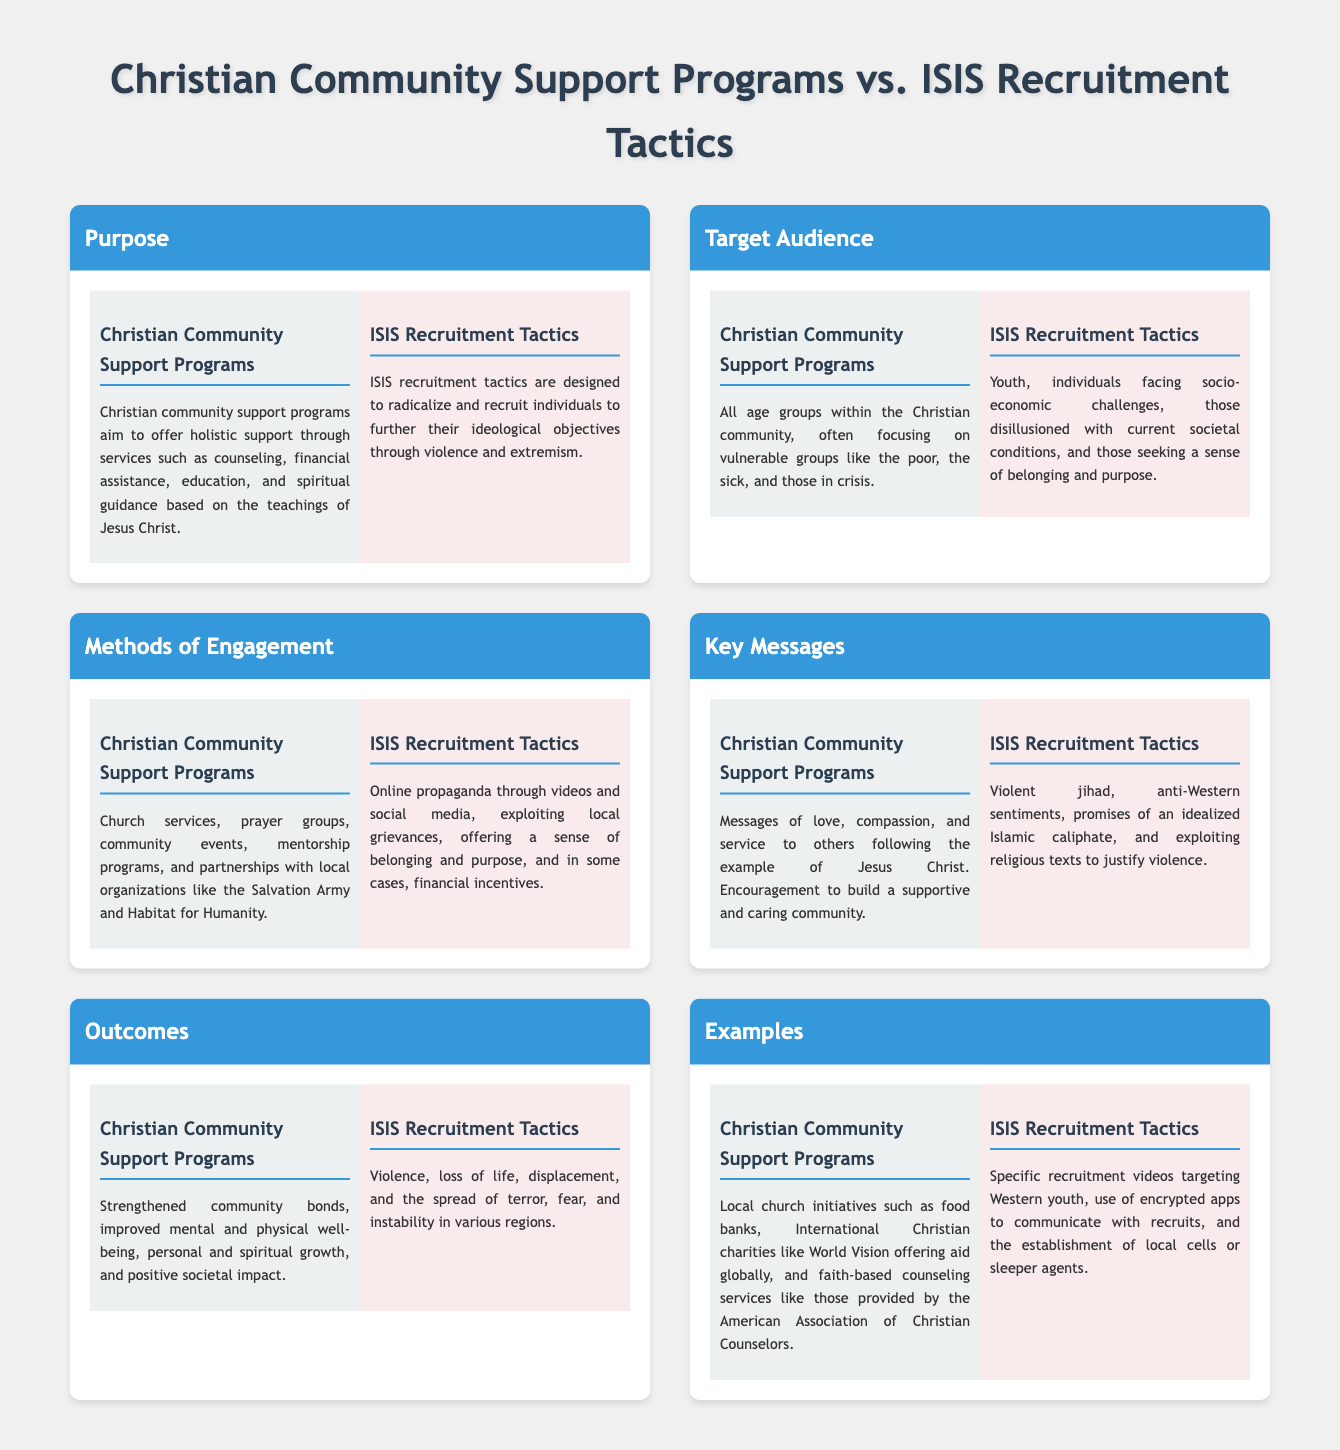What is the purpose of Christian Community Support Programs? The purpose of Christian Community Support Programs is to offer holistic support through services such as counseling, financial assistance, education, and spiritual guidance based on the teachings of Jesus Christ.
Answer: Holistic support Who is the target audience for ISIS recruitment tactics? The target audience for ISIS recruitment tactics includes youth, individuals facing socio-economic challenges, and those disillusioned with current societal conditions.
Answer: Youth, socio-economic individuals, disillusioned What methods do Christian Community Support Programs use for engagement? Christian Community Support Programs engage through church services, prayer groups, community events, mentorship programs, and partnerships.
Answer: Church services, prayer groups, community events What key message do Christian Community Support Programs promote? The key message promoted by Christian Community Support Programs is encouragement to build a supportive and caring community.
Answer: Supportive and caring community What is the outcome of ISIS recruitment tactics? The outcome of ISIS recruitment tactics includes violence, loss of life, and the spread of terror.
Answer: Violence, loss of life, terror What is an example of a Christian Community Support Program? An example of a Christian Community Support Program is local church initiatives such as food banks.
Answer: Local church initiatives, food banks How do ISIS recruitment tactics exploit local grievances? ISIS recruitment tactics exploit local grievances by using online propaganda and social media to create a sense of belonging and purpose.
Answer: Online propaganda, social media What kind of key messages do ISIS recruitment tactics use? The key messages used by ISIS recruitment tactics include violent jihad and anti-Western sentiments.
Answer: Violent jihad, anti-Western sentiments 